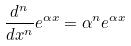<formula> <loc_0><loc_0><loc_500><loc_500>\frac { d ^ { n } } { d x ^ { n } } e ^ { \alpha x } = \alpha ^ { n } e ^ { \alpha x }</formula> 